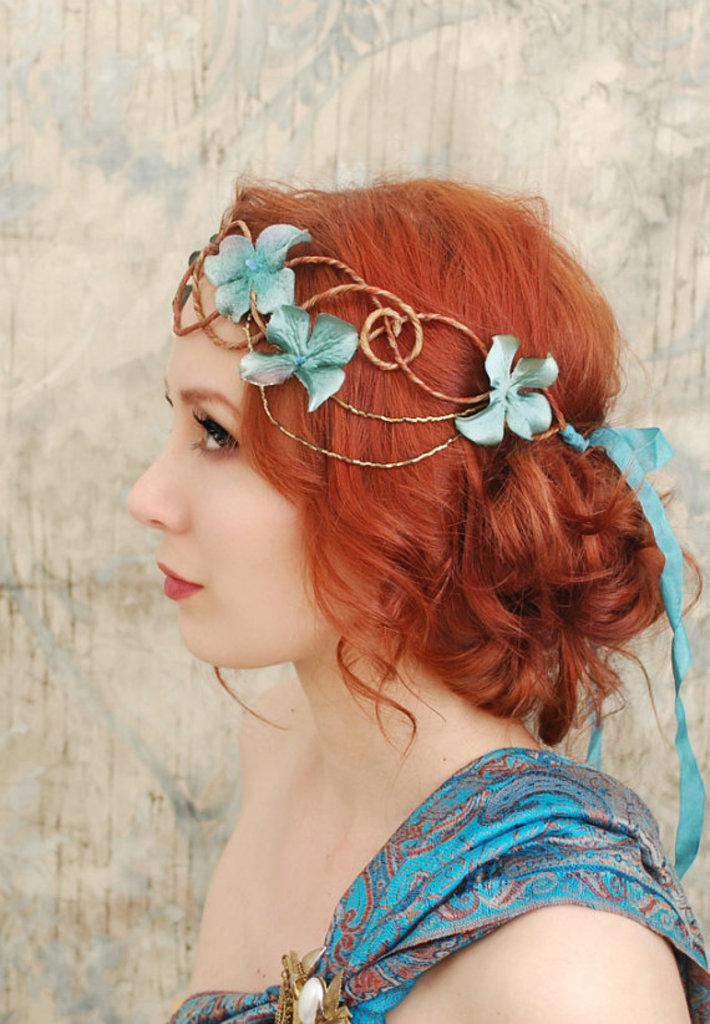Who is present in the image? There is a woman in the image. What is the woman wearing? The woman is wearing a blue dress. What accessory is the woman wearing on her head? The woman has a tiara on her head. What can be seen in the background of the image? There is a wall in the background of the image. What type of jewel can be seen in the river in the image? There is no river or jewel present in the image; it features a woman wearing a blue dress and a tiara, with a wall in the background. 